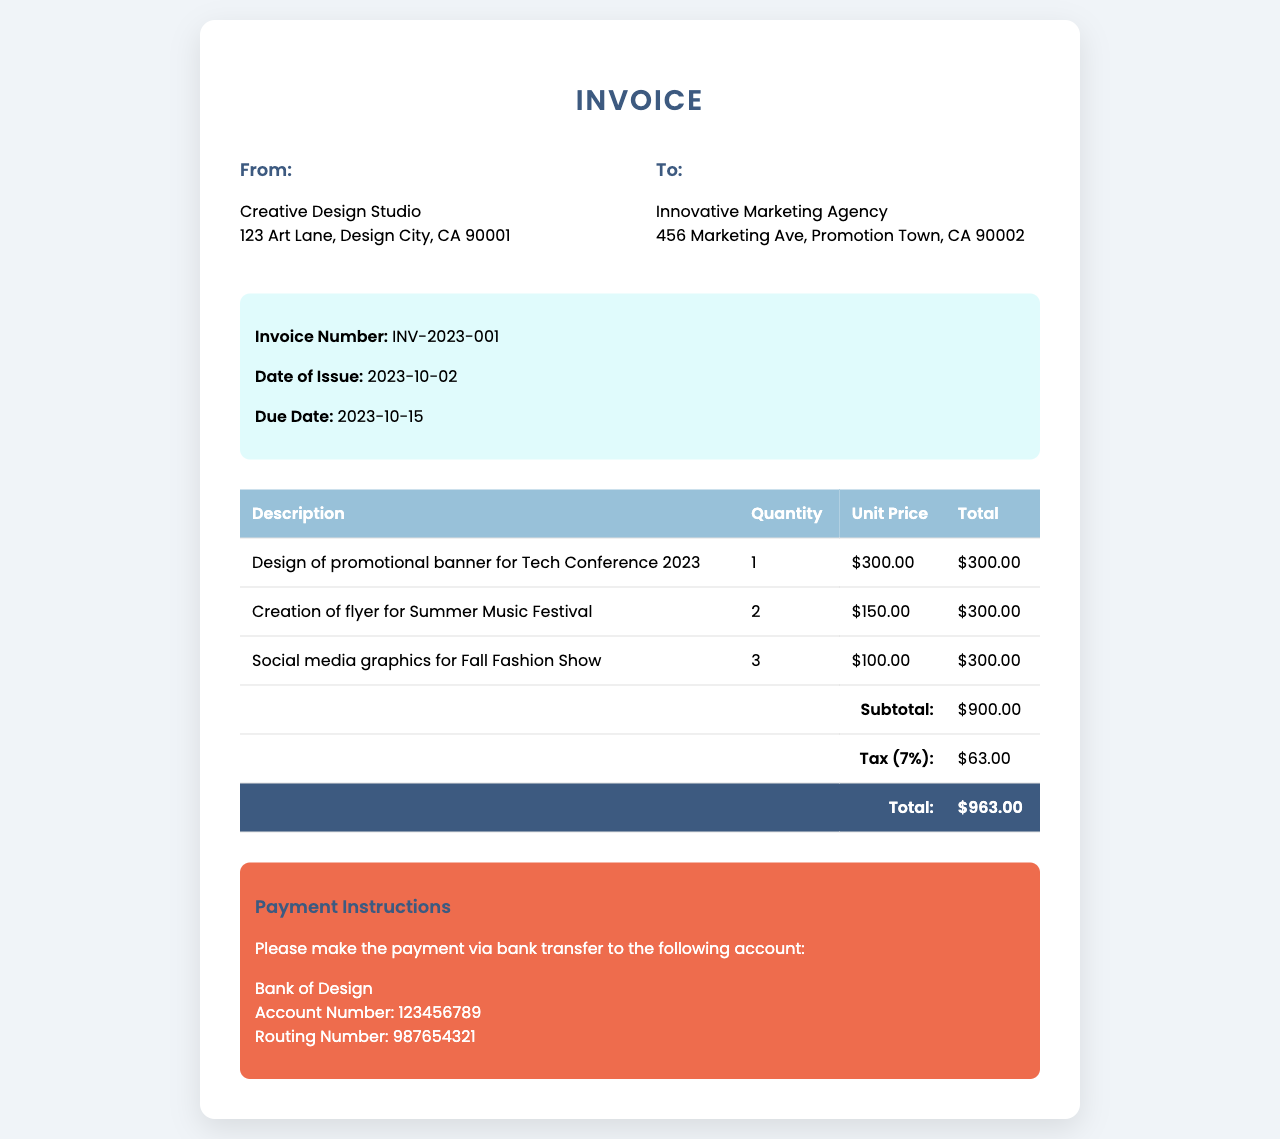What is the invoice number? The invoice number is specifically indicated in the invoice meta section of the document, which is INV-2023-001.
Answer: INV-2023-001 What is the due date for payment? The due date is provided in the invoice meta section, which states that payments are due on 2023-10-15.
Answer: 2023-10-15 How many promotional banners were designed for the Tech Conference? The invoice lists a quantity of 1 for the design of the promotional banner for the Tech Conference 2023.
Answer: 1 What is the subtotal amount before tax? The subtotal amount is the sum of the individual totals listed in the invoice, which is $900.00.
Answer: $900.00 What percentage tax is applied to the invoice? The invoice indicates a tax rate of 7%, which is applied to the subtotal.
Answer: 7% What is the total amount to be paid? The total amount, including tax, is clearly listed at the bottom of the invoice as $963.00.
Answer: $963.00 Who is the client for this invoice? The client’s name and address are specified in the client details section: Innovative Marketing Agency at 456 Marketing Ave, Promotion Town, CA 90002.
Answer: Innovative Marketing Agency What payment method is requested? The invoice specifies that payment should be made via bank transfer to the Bank of Design.
Answer: bank transfer How many social media graphics were created for the Fall Fashion Show? The invoice states that 3 social media graphics were created for the Fall Fashion Show.
Answer: 3 